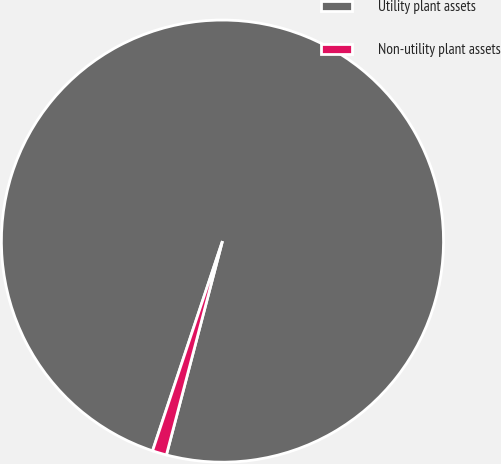<chart> <loc_0><loc_0><loc_500><loc_500><pie_chart><fcel>Utility plant assets<fcel>Non-utility plant assets<nl><fcel>98.96%<fcel>1.04%<nl></chart> 